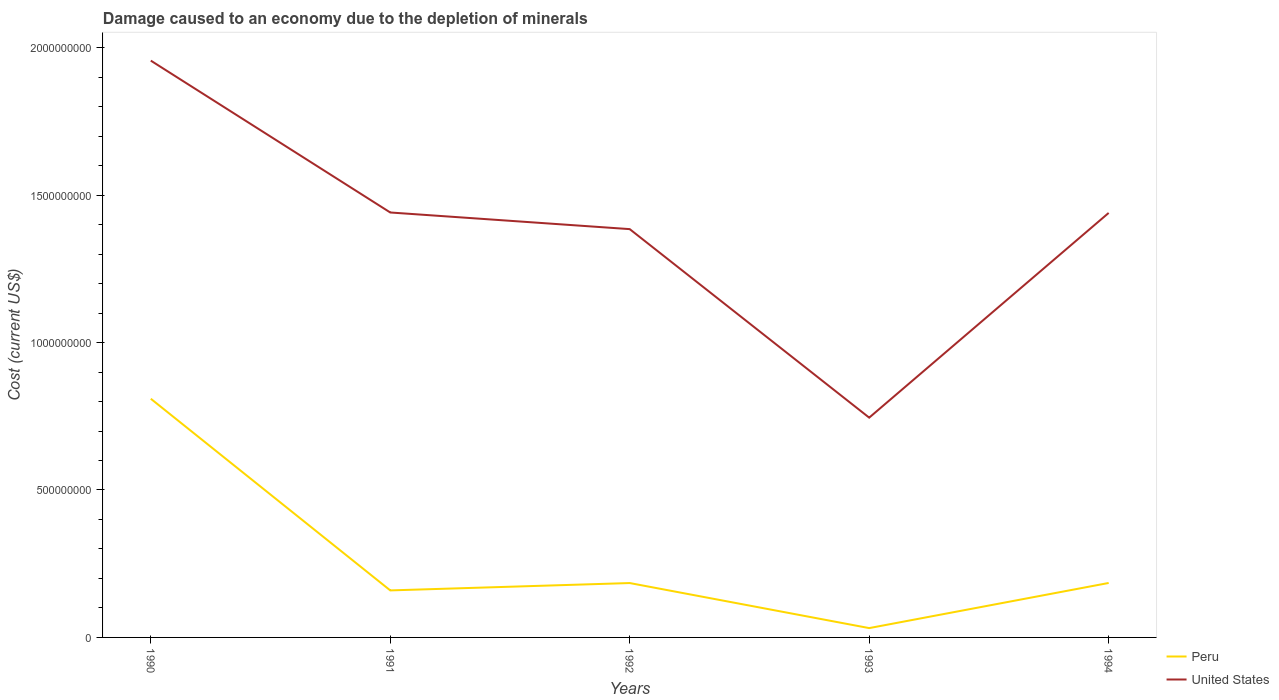Does the line corresponding to Peru intersect with the line corresponding to United States?
Make the answer very short. No. Is the number of lines equal to the number of legend labels?
Keep it short and to the point. Yes. Across all years, what is the maximum cost of damage caused due to the depletion of minerals in United States?
Ensure brevity in your answer.  7.45e+08. In which year was the cost of damage caused due to the depletion of minerals in United States maximum?
Offer a terse response. 1993. What is the total cost of damage caused due to the depletion of minerals in Peru in the graph?
Keep it short and to the point. 7.78e+08. What is the difference between the highest and the second highest cost of damage caused due to the depletion of minerals in United States?
Provide a succinct answer. 1.21e+09. Is the cost of damage caused due to the depletion of minerals in United States strictly greater than the cost of damage caused due to the depletion of minerals in Peru over the years?
Keep it short and to the point. No. How many years are there in the graph?
Offer a terse response. 5. Are the values on the major ticks of Y-axis written in scientific E-notation?
Provide a succinct answer. No. What is the title of the graph?
Your response must be concise. Damage caused to an economy due to the depletion of minerals. Does "Slovenia" appear as one of the legend labels in the graph?
Offer a very short reply. No. What is the label or title of the Y-axis?
Your answer should be compact. Cost (current US$). What is the Cost (current US$) of Peru in 1990?
Your response must be concise. 8.09e+08. What is the Cost (current US$) in United States in 1990?
Your answer should be very brief. 1.96e+09. What is the Cost (current US$) in Peru in 1991?
Offer a very short reply. 1.59e+08. What is the Cost (current US$) of United States in 1991?
Provide a short and direct response. 1.44e+09. What is the Cost (current US$) in Peru in 1992?
Provide a short and direct response. 1.84e+08. What is the Cost (current US$) of United States in 1992?
Keep it short and to the point. 1.38e+09. What is the Cost (current US$) of Peru in 1993?
Your response must be concise. 3.17e+07. What is the Cost (current US$) in United States in 1993?
Keep it short and to the point. 7.45e+08. What is the Cost (current US$) in Peru in 1994?
Ensure brevity in your answer.  1.85e+08. What is the Cost (current US$) in United States in 1994?
Offer a terse response. 1.44e+09. Across all years, what is the maximum Cost (current US$) of Peru?
Offer a terse response. 8.09e+08. Across all years, what is the maximum Cost (current US$) in United States?
Offer a terse response. 1.96e+09. Across all years, what is the minimum Cost (current US$) of Peru?
Your response must be concise. 3.17e+07. Across all years, what is the minimum Cost (current US$) in United States?
Ensure brevity in your answer.  7.45e+08. What is the total Cost (current US$) of Peru in the graph?
Give a very brief answer. 1.37e+09. What is the total Cost (current US$) in United States in the graph?
Your response must be concise. 6.97e+09. What is the difference between the Cost (current US$) in Peru in 1990 and that in 1991?
Your answer should be compact. 6.50e+08. What is the difference between the Cost (current US$) in United States in 1990 and that in 1991?
Offer a terse response. 5.15e+08. What is the difference between the Cost (current US$) of Peru in 1990 and that in 1992?
Your answer should be very brief. 6.25e+08. What is the difference between the Cost (current US$) in United States in 1990 and that in 1992?
Offer a terse response. 5.71e+08. What is the difference between the Cost (current US$) of Peru in 1990 and that in 1993?
Make the answer very short. 7.78e+08. What is the difference between the Cost (current US$) in United States in 1990 and that in 1993?
Provide a short and direct response. 1.21e+09. What is the difference between the Cost (current US$) in Peru in 1990 and that in 1994?
Offer a terse response. 6.25e+08. What is the difference between the Cost (current US$) of United States in 1990 and that in 1994?
Offer a very short reply. 5.16e+08. What is the difference between the Cost (current US$) of Peru in 1991 and that in 1992?
Offer a terse response. -2.50e+07. What is the difference between the Cost (current US$) in United States in 1991 and that in 1992?
Ensure brevity in your answer.  5.65e+07. What is the difference between the Cost (current US$) in Peru in 1991 and that in 1993?
Provide a short and direct response. 1.28e+08. What is the difference between the Cost (current US$) in United States in 1991 and that in 1993?
Offer a terse response. 6.96e+08. What is the difference between the Cost (current US$) in Peru in 1991 and that in 1994?
Provide a short and direct response. -2.52e+07. What is the difference between the Cost (current US$) of United States in 1991 and that in 1994?
Keep it short and to the point. 1.52e+06. What is the difference between the Cost (current US$) of Peru in 1992 and that in 1993?
Provide a succinct answer. 1.53e+08. What is the difference between the Cost (current US$) of United States in 1992 and that in 1993?
Offer a terse response. 6.39e+08. What is the difference between the Cost (current US$) of Peru in 1992 and that in 1994?
Give a very brief answer. -2.47e+05. What is the difference between the Cost (current US$) in United States in 1992 and that in 1994?
Make the answer very short. -5.49e+07. What is the difference between the Cost (current US$) in Peru in 1993 and that in 1994?
Keep it short and to the point. -1.53e+08. What is the difference between the Cost (current US$) in United States in 1993 and that in 1994?
Make the answer very short. -6.94e+08. What is the difference between the Cost (current US$) in Peru in 1990 and the Cost (current US$) in United States in 1991?
Your response must be concise. -6.32e+08. What is the difference between the Cost (current US$) in Peru in 1990 and the Cost (current US$) in United States in 1992?
Your answer should be very brief. -5.75e+08. What is the difference between the Cost (current US$) in Peru in 1990 and the Cost (current US$) in United States in 1993?
Your answer should be compact. 6.40e+07. What is the difference between the Cost (current US$) in Peru in 1990 and the Cost (current US$) in United States in 1994?
Give a very brief answer. -6.30e+08. What is the difference between the Cost (current US$) in Peru in 1991 and the Cost (current US$) in United States in 1992?
Make the answer very short. -1.23e+09. What is the difference between the Cost (current US$) in Peru in 1991 and the Cost (current US$) in United States in 1993?
Offer a terse response. -5.86e+08. What is the difference between the Cost (current US$) of Peru in 1991 and the Cost (current US$) of United States in 1994?
Your answer should be compact. -1.28e+09. What is the difference between the Cost (current US$) in Peru in 1992 and the Cost (current US$) in United States in 1993?
Offer a terse response. -5.61e+08. What is the difference between the Cost (current US$) of Peru in 1992 and the Cost (current US$) of United States in 1994?
Offer a terse response. -1.26e+09. What is the difference between the Cost (current US$) of Peru in 1993 and the Cost (current US$) of United States in 1994?
Your answer should be compact. -1.41e+09. What is the average Cost (current US$) in Peru per year?
Offer a terse response. 2.74e+08. What is the average Cost (current US$) in United States per year?
Give a very brief answer. 1.39e+09. In the year 1990, what is the difference between the Cost (current US$) in Peru and Cost (current US$) in United States?
Keep it short and to the point. -1.15e+09. In the year 1991, what is the difference between the Cost (current US$) of Peru and Cost (current US$) of United States?
Provide a succinct answer. -1.28e+09. In the year 1992, what is the difference between the Cost (current US$) of Peru and Cost (current US$) of United States?
Give a very brief answer. -1.20e+09. In the year 1993, what is the difference between the Cost (current US$) in Peru and Cost (current US$) in United States?
Ensure brevity in your answer.  -7.14e+08. In the year 1994, what is the difference between the Cost (current US$) of Peru and Cost (current US$) of United States?
Ensure brevity in your answer.  -1.25e+09. What is the ratio of the Cost (current US$) in Peru in 1990 to that in 1991?
Provide a succinct answer. 5.08. What is the ratio of the Cost (current US$) of United States in 1990 to that in 1991?
Give a very brief answer. 1.36. What is the ratio of the Cost (current US$) of Peru in 1990 to that in 1992?
Your answer should be compact. 4.39. What is the ratio of the Cost (current US$) of United States in 1990 to that in 1992?
Offer a very short reply. 1.41. What is the ratio of the Cost (current US$) in Peru in 1990 to that in 1993?
Give a very brief answer. 25.57. What is the ratio of the Cost (current US$) of United States in 1990 to that in 1993?
Ensure brevity in your answer.  2.62. What is the ratio of the Cost (current US$) of Peru in 1990 to that in 1994?
Provide a short and direct response. 4.38. What is the ratio of the Cost (current US$) of United States in 1990 to that in 1994?
Keep it short and to the point. 1.36. What is the ratio of the Cost (current US$) of Peru in 1991 to that in 1992?
Make the answer very short. 0.86. What is the ratio of the Cost (current US$) of United States in 1991 to that in 1992?
Make the answer very short. 1.04. What is the ratio of the Cost (current US$) in Peru in 1991 to that in 1993?
Offer a very short reply. 5.04. What is the ratio of the Cost (current US$) in United States in 1991 to that in 1993?
Make the answer very short. 1.93. What is the ratio of the Cost (current US$) of Peru in 1991 to that in 1994?
Offer a very short reply. 0.86. What is the ratio of the Cost (current US$) in United States in 1991 to that in 1994?
Keep it short and to the point. 1. What is the ratio of the Cost (current US$) in Peru in 1992 to that in 1993?
Provide a succinct answer. 5.83. What is the ratio of the Cost (current US$) of United States in 1992 to that in 1993?
Your answer should be very brief. 1.86. What is the ratio of the Cost (current US$) in United States in 1992 to that in 1994?
Offer a terse response. 0.96. What is the ratio of the Cost (current US$) in Peru in 1993 to that in 1994?
Give a very brief answer. 0.17. What is the ratio of the Cost (current US$) of United States in 1993 to that in 1994?
Your answer should be compact. 0.52. What is the difference between the highest and the second highest Cost (current US$) of Peru?
Ensure brevity in your answer.  6.25e+08. What is the difference between the highest and the second highest Cost (current US$) of United States?
Offer a terse response. 5.15e+08. What is the difference between the highest and the lowest Cost (current US$) of Peru?
Give a very brief answer. 7.78e+08. What is the difference between the highest and the lowest Cost (current US$) in United States?
Your answer should be very brief. 1.21e+09. 